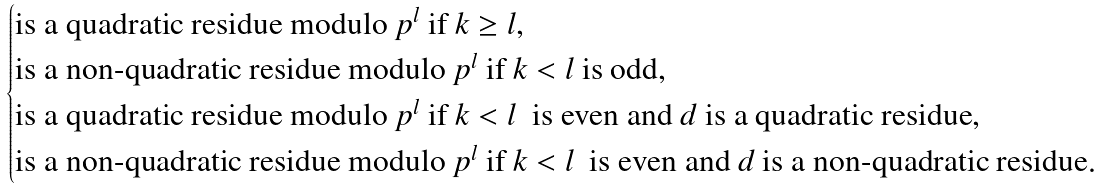Convert formula to latex. <formula><loc_0><loc_0><loc_500><loc_500>\begin{cases} \text {is a quadratic residue modulo} \ p ^ { l } \ \text {if} \ k \geq l , \\ \text {is a non-quadratic residue modulo} \ p ^ { l } \ \text {if} \ k < l \ \text {is odd} , \\ \text {is a quadratic residue modulo} \ p ^ { l } \ \text {if} \ k < l \ \text { is even and} \ d \ \text {is a quadratic residue} , \\ \text {is a non-quadratic residue modulo} \ p ^ { l } \ \text {if} \ k < l \ \text { is even and} \ d \ \text {is a non-quadratic residue} . \end{cases}</formula> 